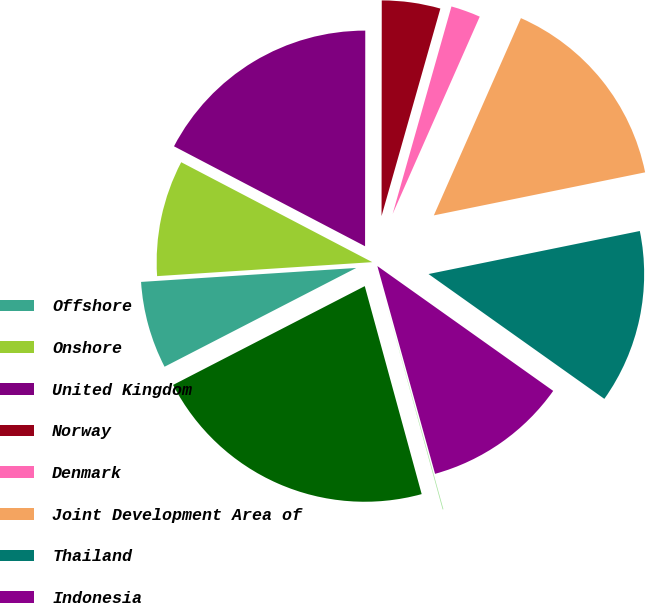Convert chart. <chart><loc_0><loc_0><loc_500><loc_500><pie_chart><fcel>Offshore<fcel>Onshore<fcel>United Kingdom<fcel>Norway<fcel>Denmark<fcel>Joint Development Area of<fcel>Thailand<fcel>Indonesia<fcel>Other<fcel>Total<nl><fcel>6.54%<fcel>8.7%<fcel>17.34%<fcel>4.38%<fcel>2.22%<fcel>15.18%<fcel>13.02%<fcel>10.86%<fcel>0.06%<fcel>21.67%<nl></chart> 